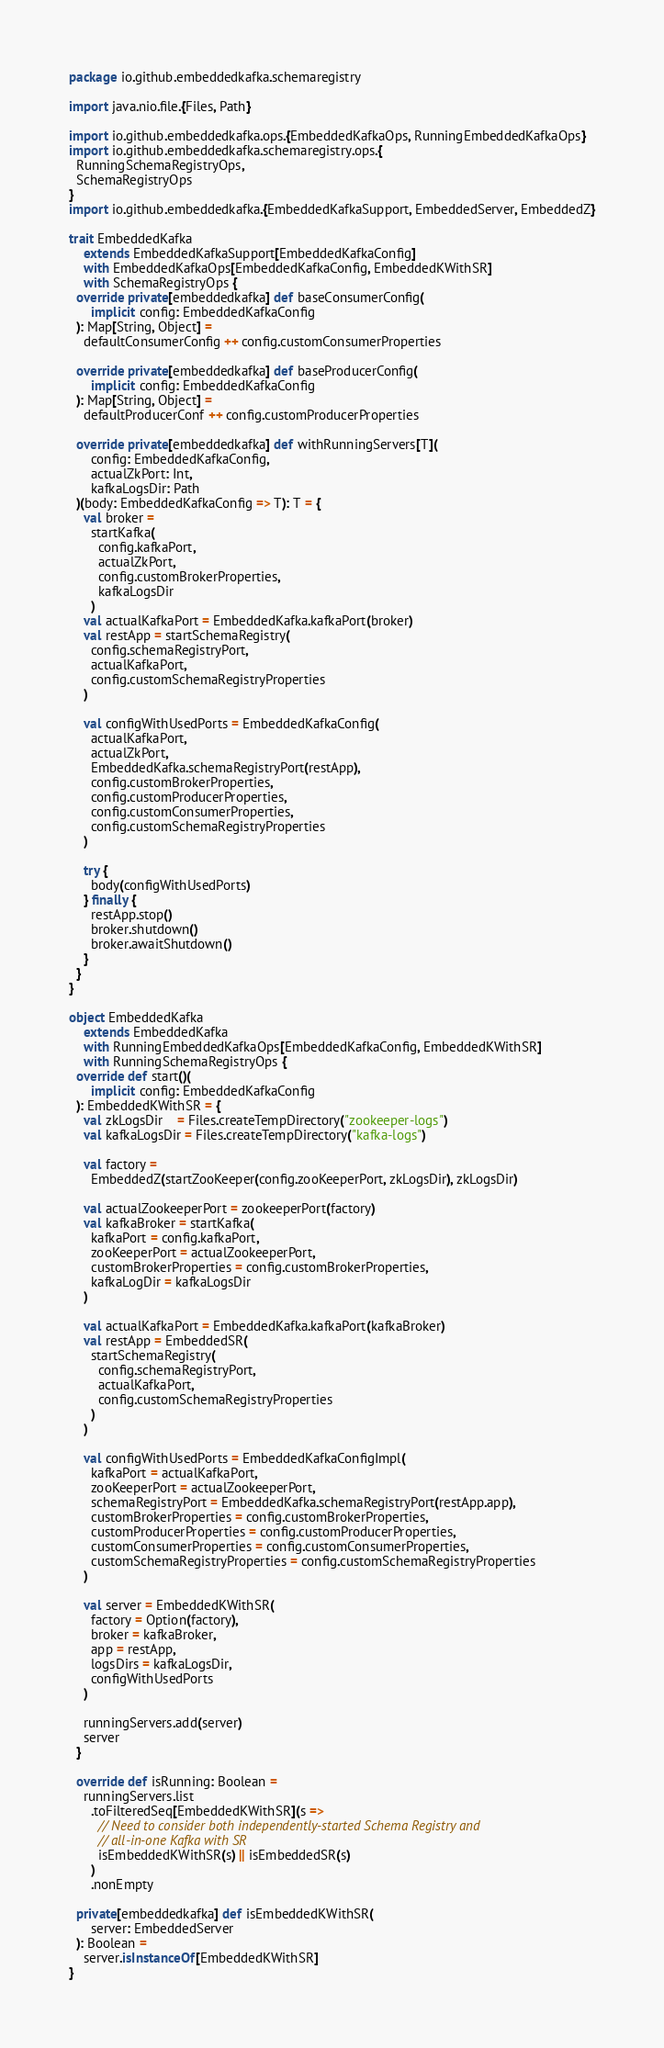Convert code to text. <code><loc_0><loc_0><loc_500><loc_500><_Scala_>package io.github.embeddedkafka.schemaregistry

import java.nio.file.{Files, Path}

import io.github.embeddedkafka.ops.{EmbeddedKafkaOps, RunningEmbeddedKafkaOps}
import io.github.embeddedkafka.schemaregistry.ops.{
  RunningSchemaRegistryOps,
  SchemaRegistryOps
}
import io.github.embeddedkafka.{EmbeddedKafkaSupport, EmbeddedServer, EmbeddedZ}

trait EmbeddedKafka
    extends EmbeddedKafkaSupport[EmbeddedKafkaConfig]
    with EmbeddedKafkaOps[EmbeddedKafkaConfig, EmbeddedKWithSR]
    with SchemaRegistryOps {
  override private[embeddedkafka] def baseConsumerConfig(
      implicit config: EmbeddedKafkaConfig
  ): Map[String, Object] =
    defaultConsumerConfig ++ config.customConsumerProperties

  override private[embeddedkafka] def baseProducerConfig(
      implicit config: EmbeddedKafkaConfig
  ): Map[String, Object] =
    defaultProducerConf ++ config.customProducerProperties

  override private[embeddedkafka] def withRunningServers[T](
      config: EmbeddedKafkaConfig,
      actualZkPort: Int,
      kafkaLogsDir: Path
  )(body: EmbeddedKafkaConfig => T): T = {
    val broker =
      startKafka(
        config.kafkaPort,
        actualZkPort,
        config.customBrokerProperties,
        kafkaLogsDir
      )
    val actualKafkaPort = EmbeddedKafka.kafkaPort(broker)
    val restApp = startSchemaRegistry(
      config.schemaRegistryPort,
      actualKafkaPort,
      config.customSchemaRegistryProperties
    )

    val configWithUsedPorts = EmbeddedKafkaConfig(
      actualKafkaPort,
      actualZkPort,
      EmbeddedKafka.schemaRegistryPort(restApp),
      config.customBrokerProperties,
      config.customProducerProperties,
      config.customConsumerProperties,
      config.customSchemaRegistryProperties
    )

    try {
      body(configWithUsedPorts)
    } finally {
      restApp.stop()
      broker.shutdown()
      broker.awaitShutdown()
    }
  }
}

object EmbeddedKafka
    extends EmbeddedKafka
    with RunningEmbeddedKafkaOps[EmbeddedKafkaConfig, EmbeddedKWithSR]
    with RunningSchemaRegistryOps {
  override def start()(
      implicit config: EmbeddedKafkaConfig
  ): EmbeddedKWithSR = {
    val zkLogsDir    = Files.createTempDirectory("zookeeper-logs")
    val kafkaLogsDir = Files.createTempDirectory("kafka-logs")

    val factory =
      EmbeddedZ(startZooKeeper(config.zooKeeperPort, zkLogsDir), zkLogsDir)

    val actualZookeeperPort = zookeeperPort(factory)
    val kafkaBroker = startKafka(
      kafkaPort = config.kafkaPort,
      zooKeeperPort = actualZookeeperPort,
      customBrokerProperties = config.customBrokerProperties,
      kafkaLogDir = kafkaLogsDir
    )

    val actualKafkaPort = EmbeddedKafka.kafkaPort(kafkaBroker)
    val restApp = EmbeddedSR(
      startSchemaRegistry(
        config.schemaRegistryPort,
        actualKafkaPort,
        config.customSchemaRegistryProperties
      )
    )

    val configWithUsedPorts = EmbeddedKafkaConfigImpl(
      kafkaPort = actualKafkaPort,
      zooKeeperPort = actualZookeeperPort,
      schemaRegistryPort = EmbeddedKafka.schemaRegistryPort(restApp.app),
      customBrokerProperties = config.customBrokerProperties,
      customProducerProperties = config.customProducerProperties,
      customConsumerProperties = config.customConsumerProperties,
      customSchemaRegistryProperties = config.customSchemaRegistryProperties
    )

    val server = EmbeddedKWithSR(
      factory = Option(factory),
      broker = kafkaBroker,
      app = restApp,
      logsDirs = kafkaLogsDir,
      configWithUsedPorts
    )

    runningServers.add(server)
    server
  }

  override def isRunning: Boolean =
    runningServers.list
      .toFilteredSeq[EmbeddedKWithSR](s =>
        // Need to consider both independently-started Schema Registry and
        // all-in-one Kafka with SR
        isEmbeddedKWithSR(s) || isEmbeddedSR(s)
      )
      .nonEmpty

  private[embeddedkafka] def isEmbeddedKWithSR(
      server: EmbeddedServer
  ): Boolean =
    server.isInstanceOf[EmbeddedKWithSR]
}
</code> 